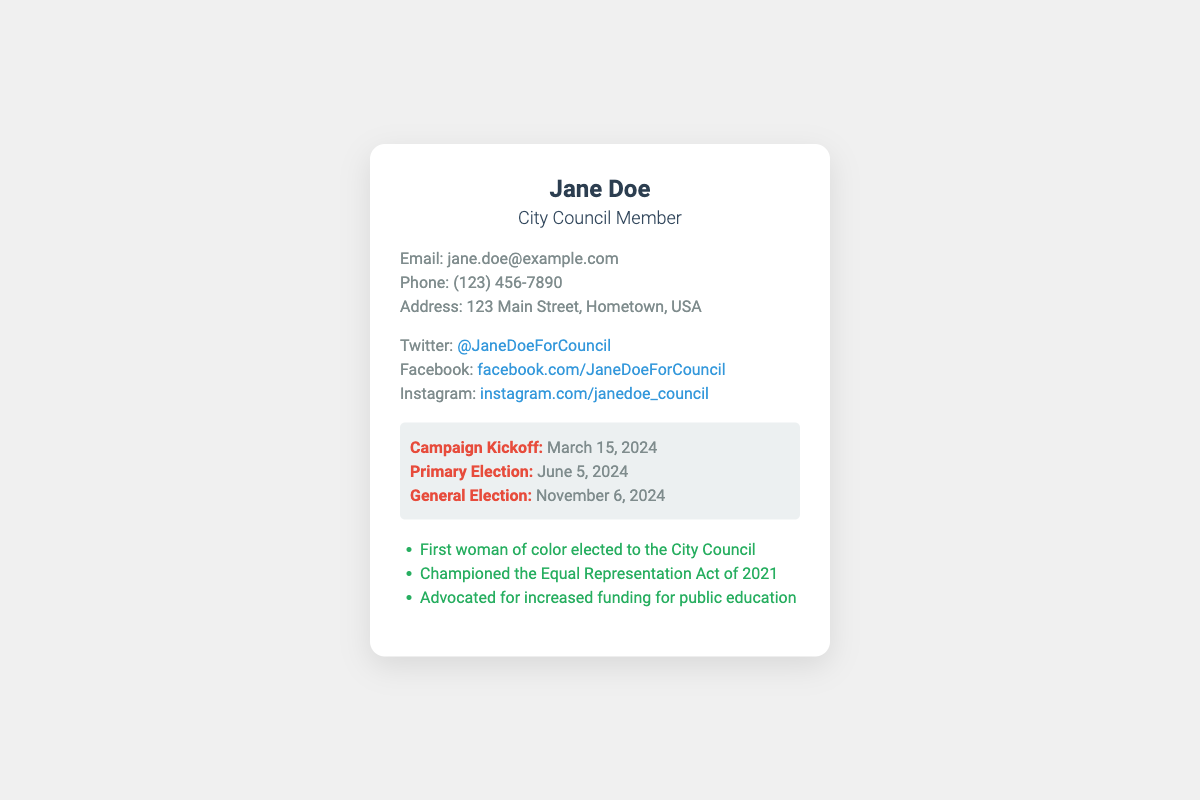What is Jane Doe's email address? The email address listed in the contact information section of the document is provided directly.
Answer: jane.doe@example.com When is the Campaign Kickoff date? The Campaign Kickoff date can be found in the campaign dates section of the document.
Answer: March 15, 2024 What social media handle is associated with Twitter? The Twitter handle is specified within the social media section of the document.
Answer: @JaneDoeForCouncil How many achievements are listed in the document? The achievements section consists of a list of three accomplishments of Jane Doe.
Answer: 3 What does Jane Doe advocate for in 2021? The advocacy mentioned is found in the achievements section detailing her legislative efforts.
Answer: Equal Representation Act Which election date is scheduled for November 6, 2024? The General Election date is clearly outlined in the campaign dates section.
Answer: General Election What is the primary campaign date? The primary election date is stated in the document under the campaign dates section.
Answer: June 5, 2024 What is the address listed on the business card? The address is found in the contact information, providing a specific location.
Answer: 123 Main Street, Hometown, USA 